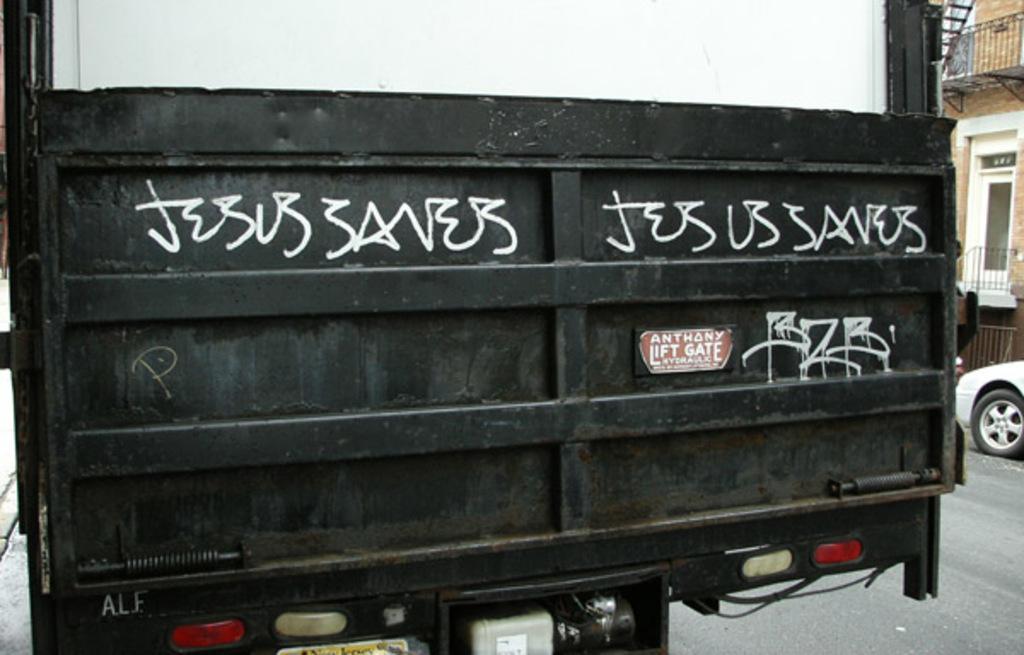Describe this image in one or two sentences. In this image in the foreground there is one vehicle, and on the vehicle there is some text. And at the bottom there are lights and engine is visible, and on the right side of the image there are buildings and car. At the bottom there is road. 